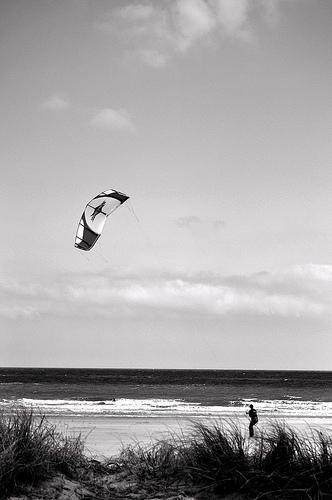How many people are visible?
Give a very brief answer. 1. 